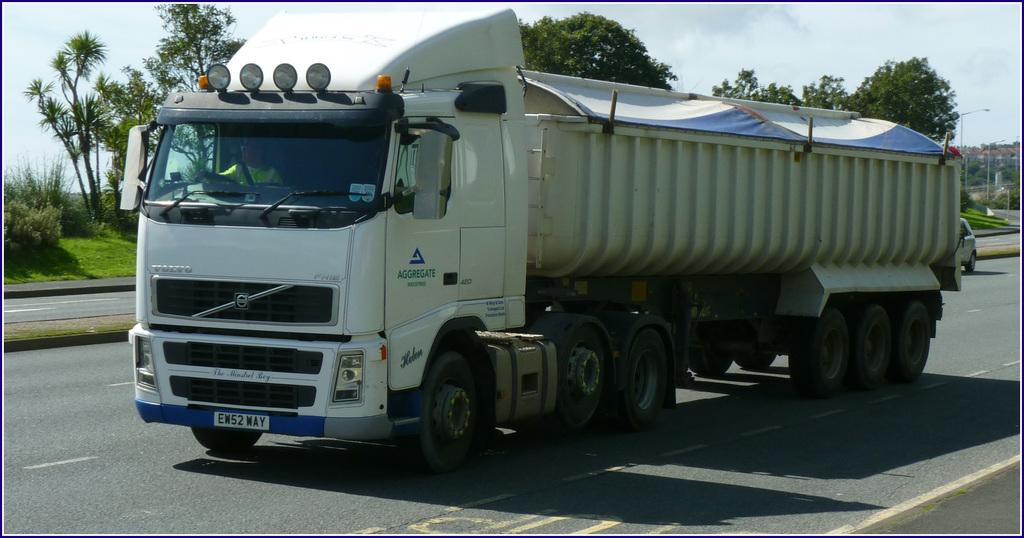What type of motor vehicle is on the road in the image? The specific type of motor vehicle is not mentioned, but it is present on the road in the image. Who is inside the motor vehicle? A person is sitting in the motor vehicle. What are the vertical structures on the sides of the road? There are street poles in the image. What are the tall structures with lights on them? There are street lights in the image. What type of vegetation can be seen in the image? Trees and bushes are visible in the image. What part of the natural environment is visible in the image? The sky is visible in the image. What can be seen in the sky? Clouds are present in the sky. What color is the orange in the bedroom in the image? There is no orange or bedroom present in the image. How does the person in the motor vehicle walk to their destination? The person in the motor vehicle is not walking; they are inside the vehicle, which is a mode of transportation. 